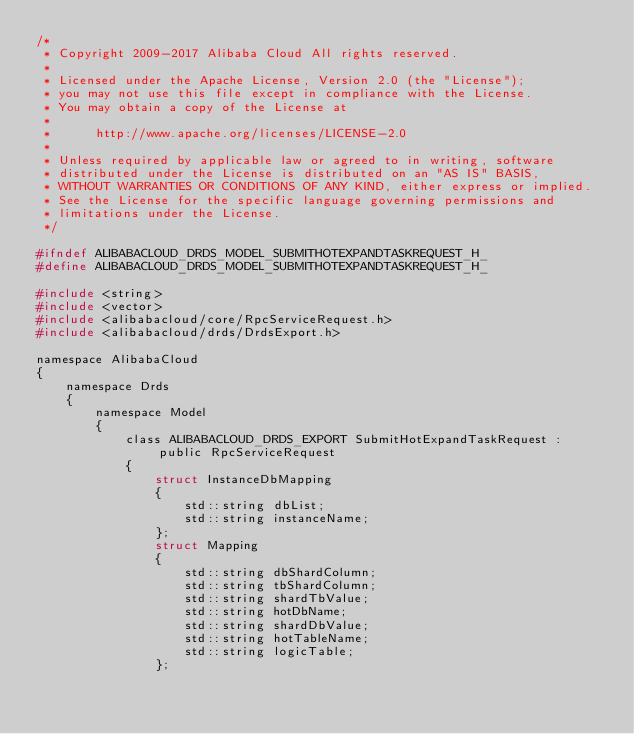<code> <loc_0><loc_0><loc_500><loc_500><_C_>/*
 * Copyright 2009-2017 Alibaba Cloud All rights reserved.
 * 
 * Licensed under the Apache License, Version 2.0 (the "License");
 * you may not use this file except in compliance with the License.
 * You may obtain a copy of the License at
 * 
 *      http://www.apache.org/licenses/LICENSE-2.0
 * 
 * Unless required by applicable law or agreed to in writing, software
 * distributed under the License is distributed on an "AS IS" BASIS,
 * WITHOUT WARRANTIES OR CONDITIONS OF ANY KIND, either express or implied.
 * See the License for the specific language governing permissions and
 * limitations under the License.
 */

#ifndef ALIBABACLOUD_DRDS_MODEL_SUBMITHOTEXPANDTASKREQUEST_H_
#define ALIBABACLOUD_DRDS_MODEL_SUBMITHOTEXPANDTASKREQUEST_H_

#include <string>
#include <vector>
#include <alibabacloud/core/RpcServiceRequest.h>
#include <alibabacloud/drds/DrdsExport.h>

namespace AlibabaCloud
{
	namespace Drds
	{
		namespace Model
		{
			class ALIBABACLOUD_DRDS_EXPORT SubmitHotExpandTaskRequest : public RpcServiceRequest
			{
				struct InstanceDbMapping
				{
					std::string dbList;
					std::string instanceName;
				};
				struct Mapping
				{
					std::string dbShardColumn;
					std::string tbShardColumn;
					std::string shardTbValue;
					std::string hotDbName;
					std::string shardDbValue;
					std::string hotTableName;
					std::string logicTable;
				};</code> 